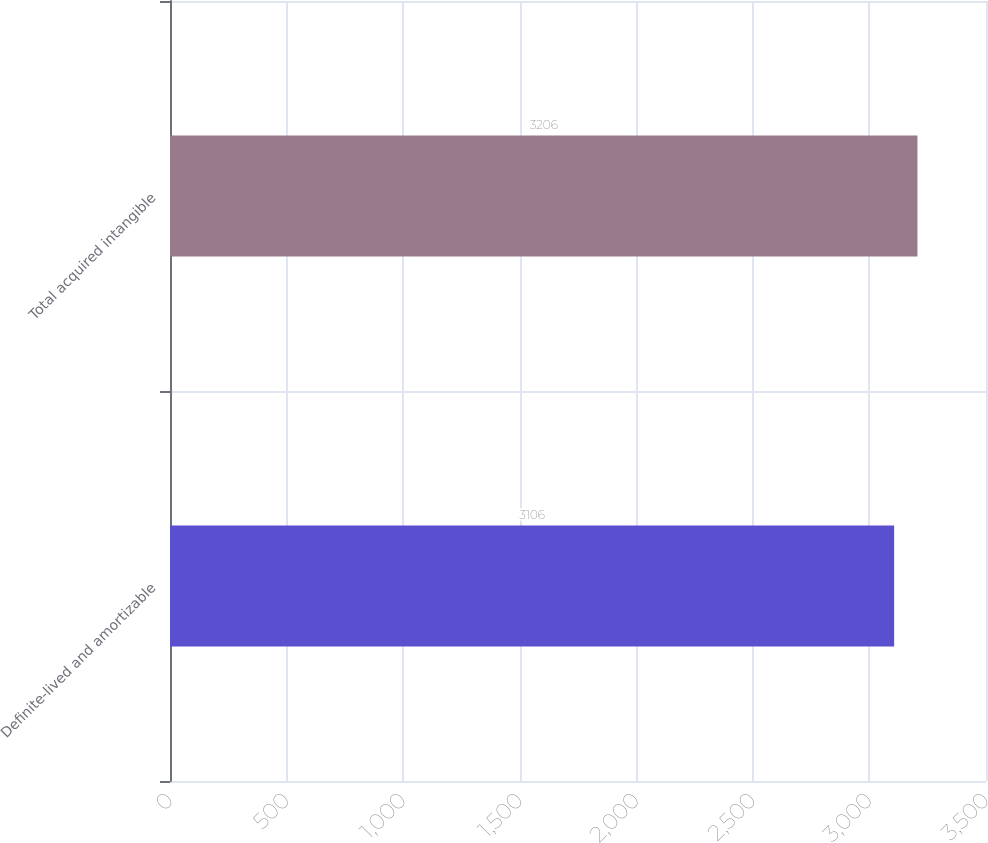<chart> <loc_0><loc_0><loc_500><loc_500><bar_chart><fcel>Definite-lived and amortizable<fcel>Total acquired intangible<nl><fcel>3106<fcel>3206<nl></chart> 